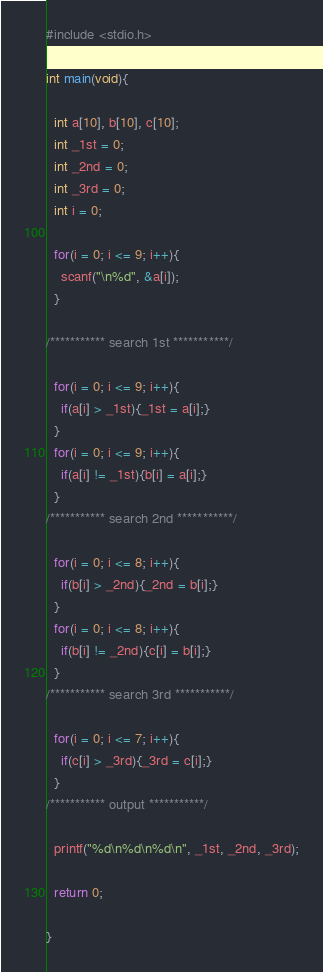Convert code to text. <code><loc_0><loc_0><loc_500><loc_500><_C_>#include <stdio.h>

int main(void){

  int a[10], b[10], c[10];
  int _1st = 0;
  int _2nd = 0;
  int _3rd = 0;
  int i = 0;
  
  for(i = 0; i <= 9; i++){
    scanf("\n%d", &a[i]);
  }

/*********** search 1st ***********/

  for(i = 0; i <= 9; i++){
    if(a[i] > _1st){_1st = a[i];}
  }
  for(i = 0; i <= 9; i++){
    if(a[i] != _1st){b[i] = a[i];}
  }
/*********** search 2nd ***********/

  for(i = 0; i <= 8; i++){
    if(b[i] > _2nd){_2nd = b[i];}
  }
  for(i = 0; i <= 8; i++){
    if(b[i] != _2nd){c[i] = b[i];}
  }
/*********** search 3rd ***********/

  for(i = 0; i <= 7; i++){
    if(c[i] > _3rd){_3rd = c[i];}
  }
/*********** output ***********/

  printf("%d\n%d\n%d\n", _1st, _2nd, _3rd);

  return 0;

}</code> 